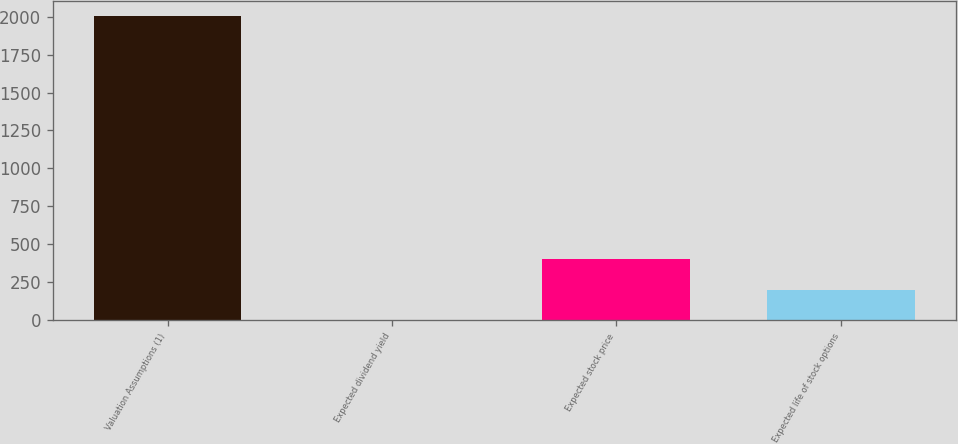<chart> <loc_0><loc_0><loc_500><loc_500><bar_chart><fcel>Valuation Assumptions (1)<fcel>Expected dividend yield<fcel>Expected stock price<fcel>Expected life of stock options<nl><fcel>2006<fcel>0.8<fcel>401.84<fcel>201.32<nl></chart> 